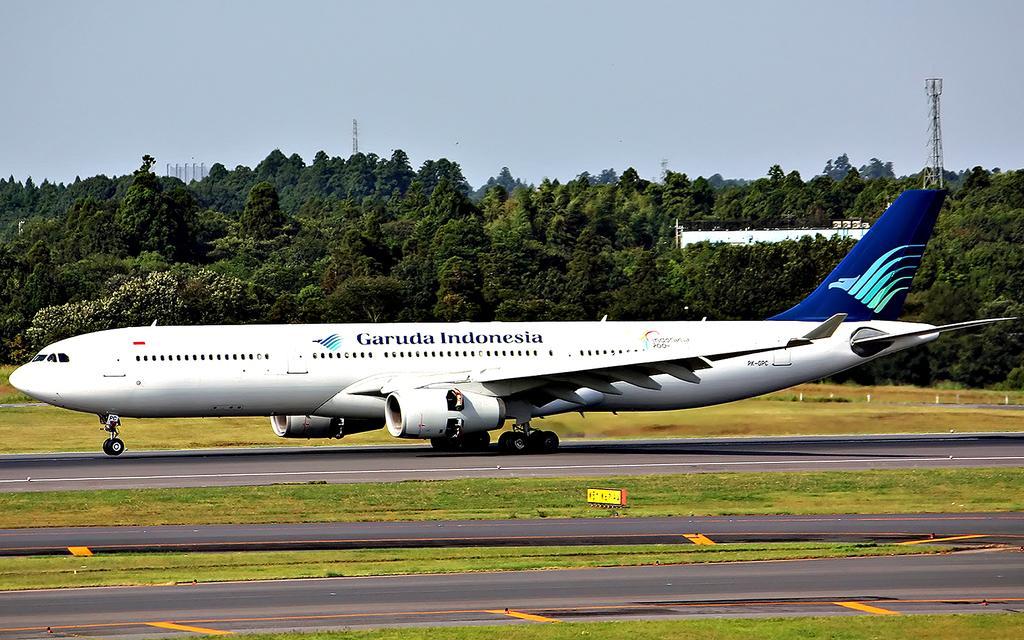Describe this image in one or two sentences. In this image we can see an airplane which is of white and blue color is on the runway and at the background of the image there are some trees, tower and clear sky. 